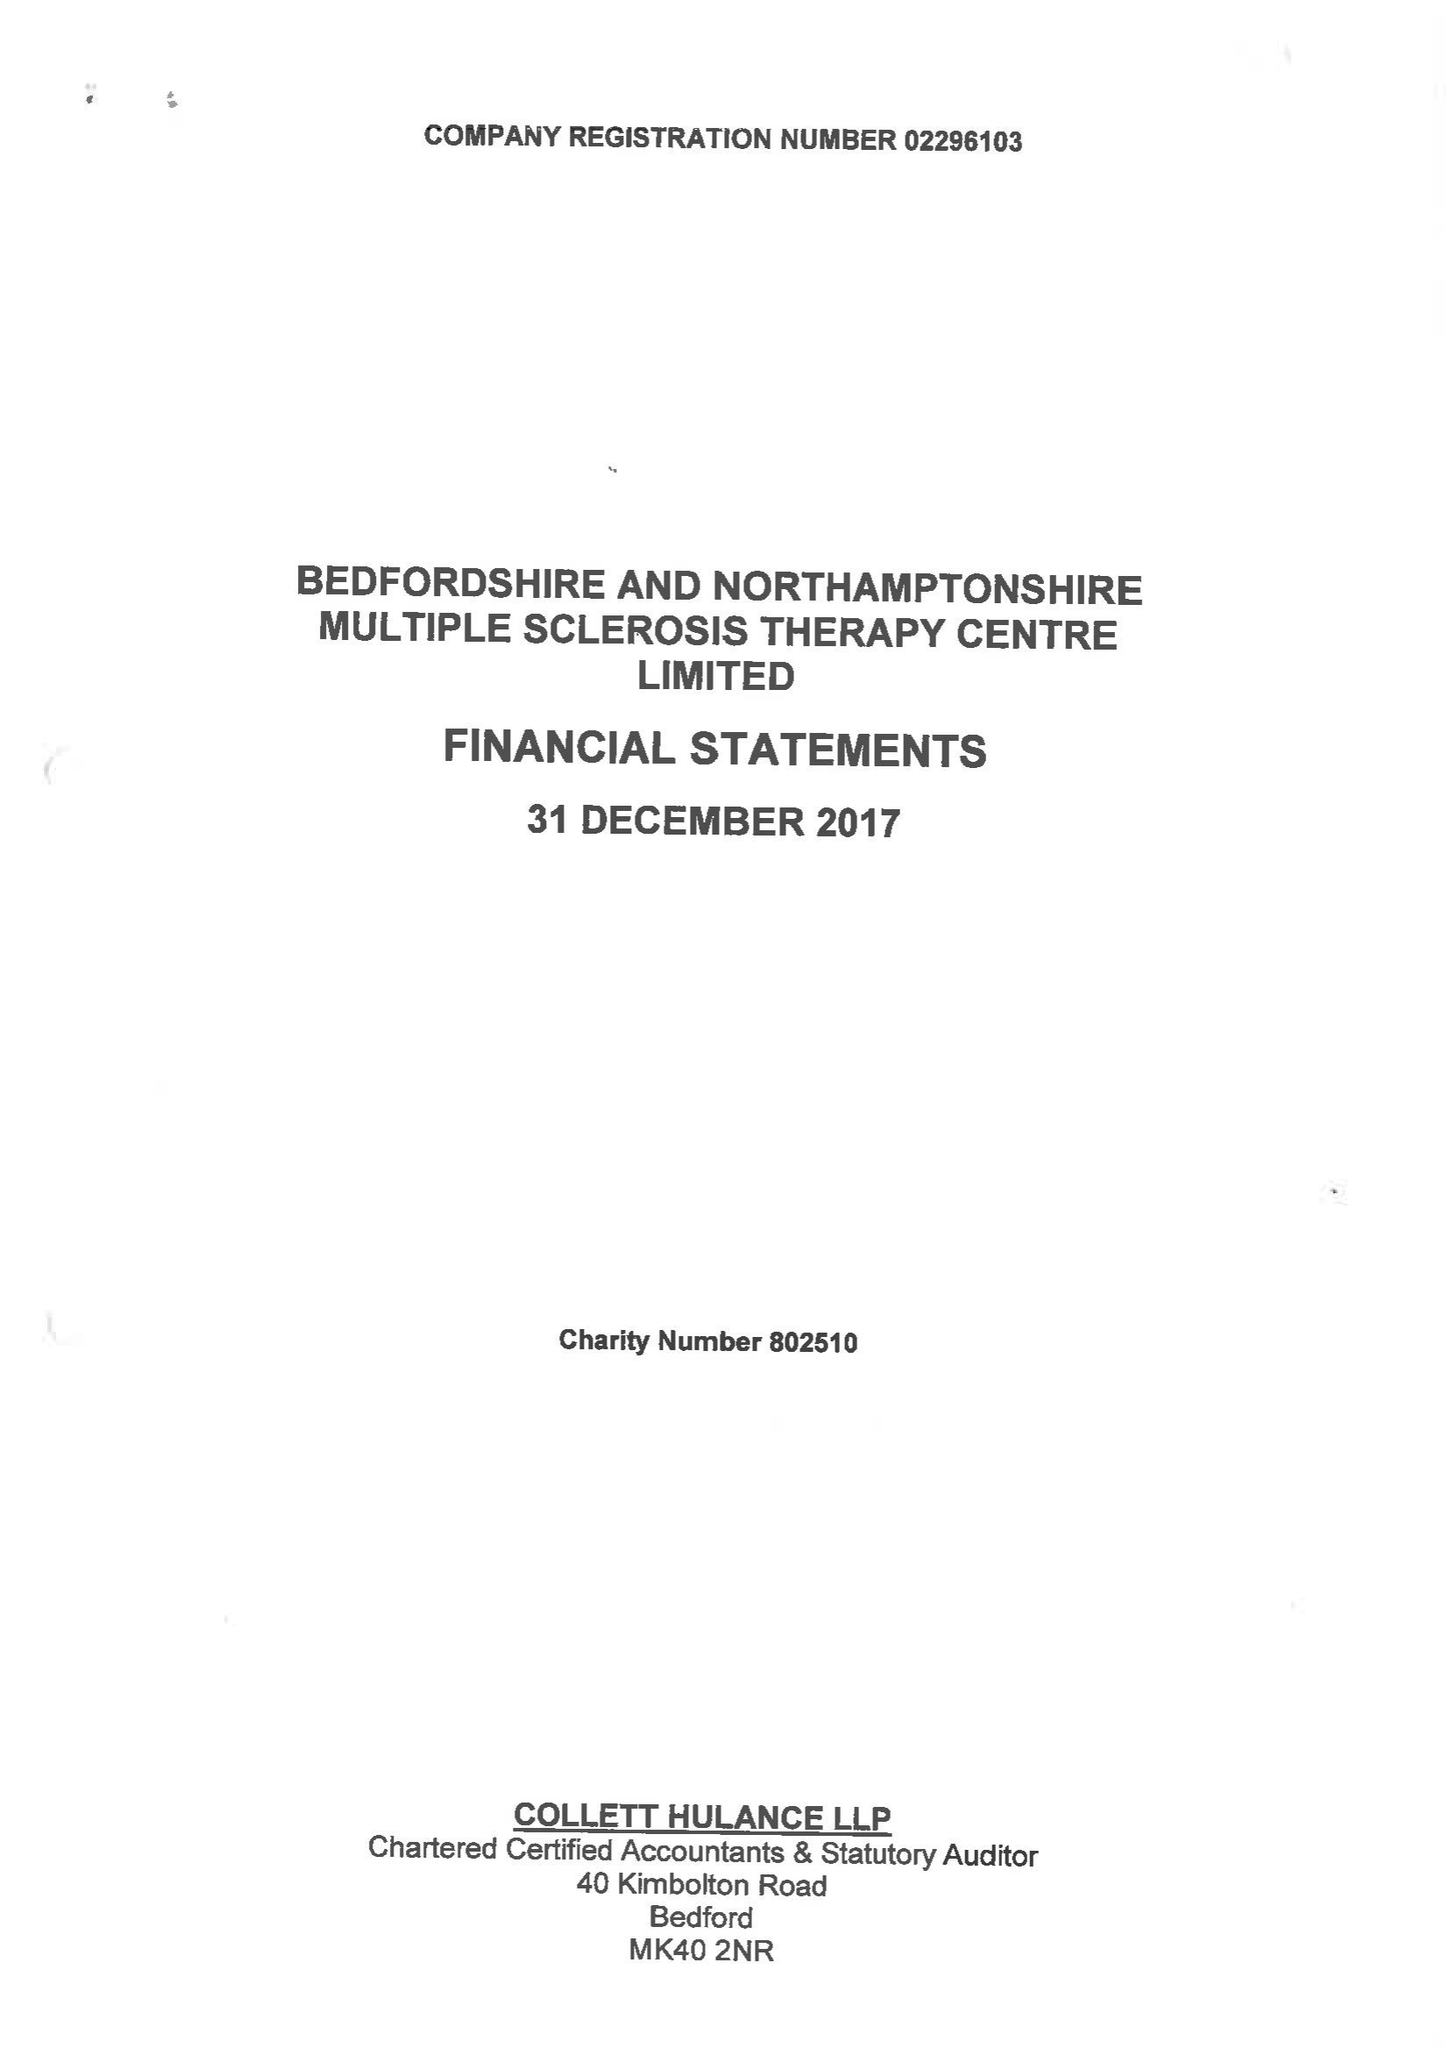What is the value for the charity_number?
Answer the question using a single word or phrase. 802510 